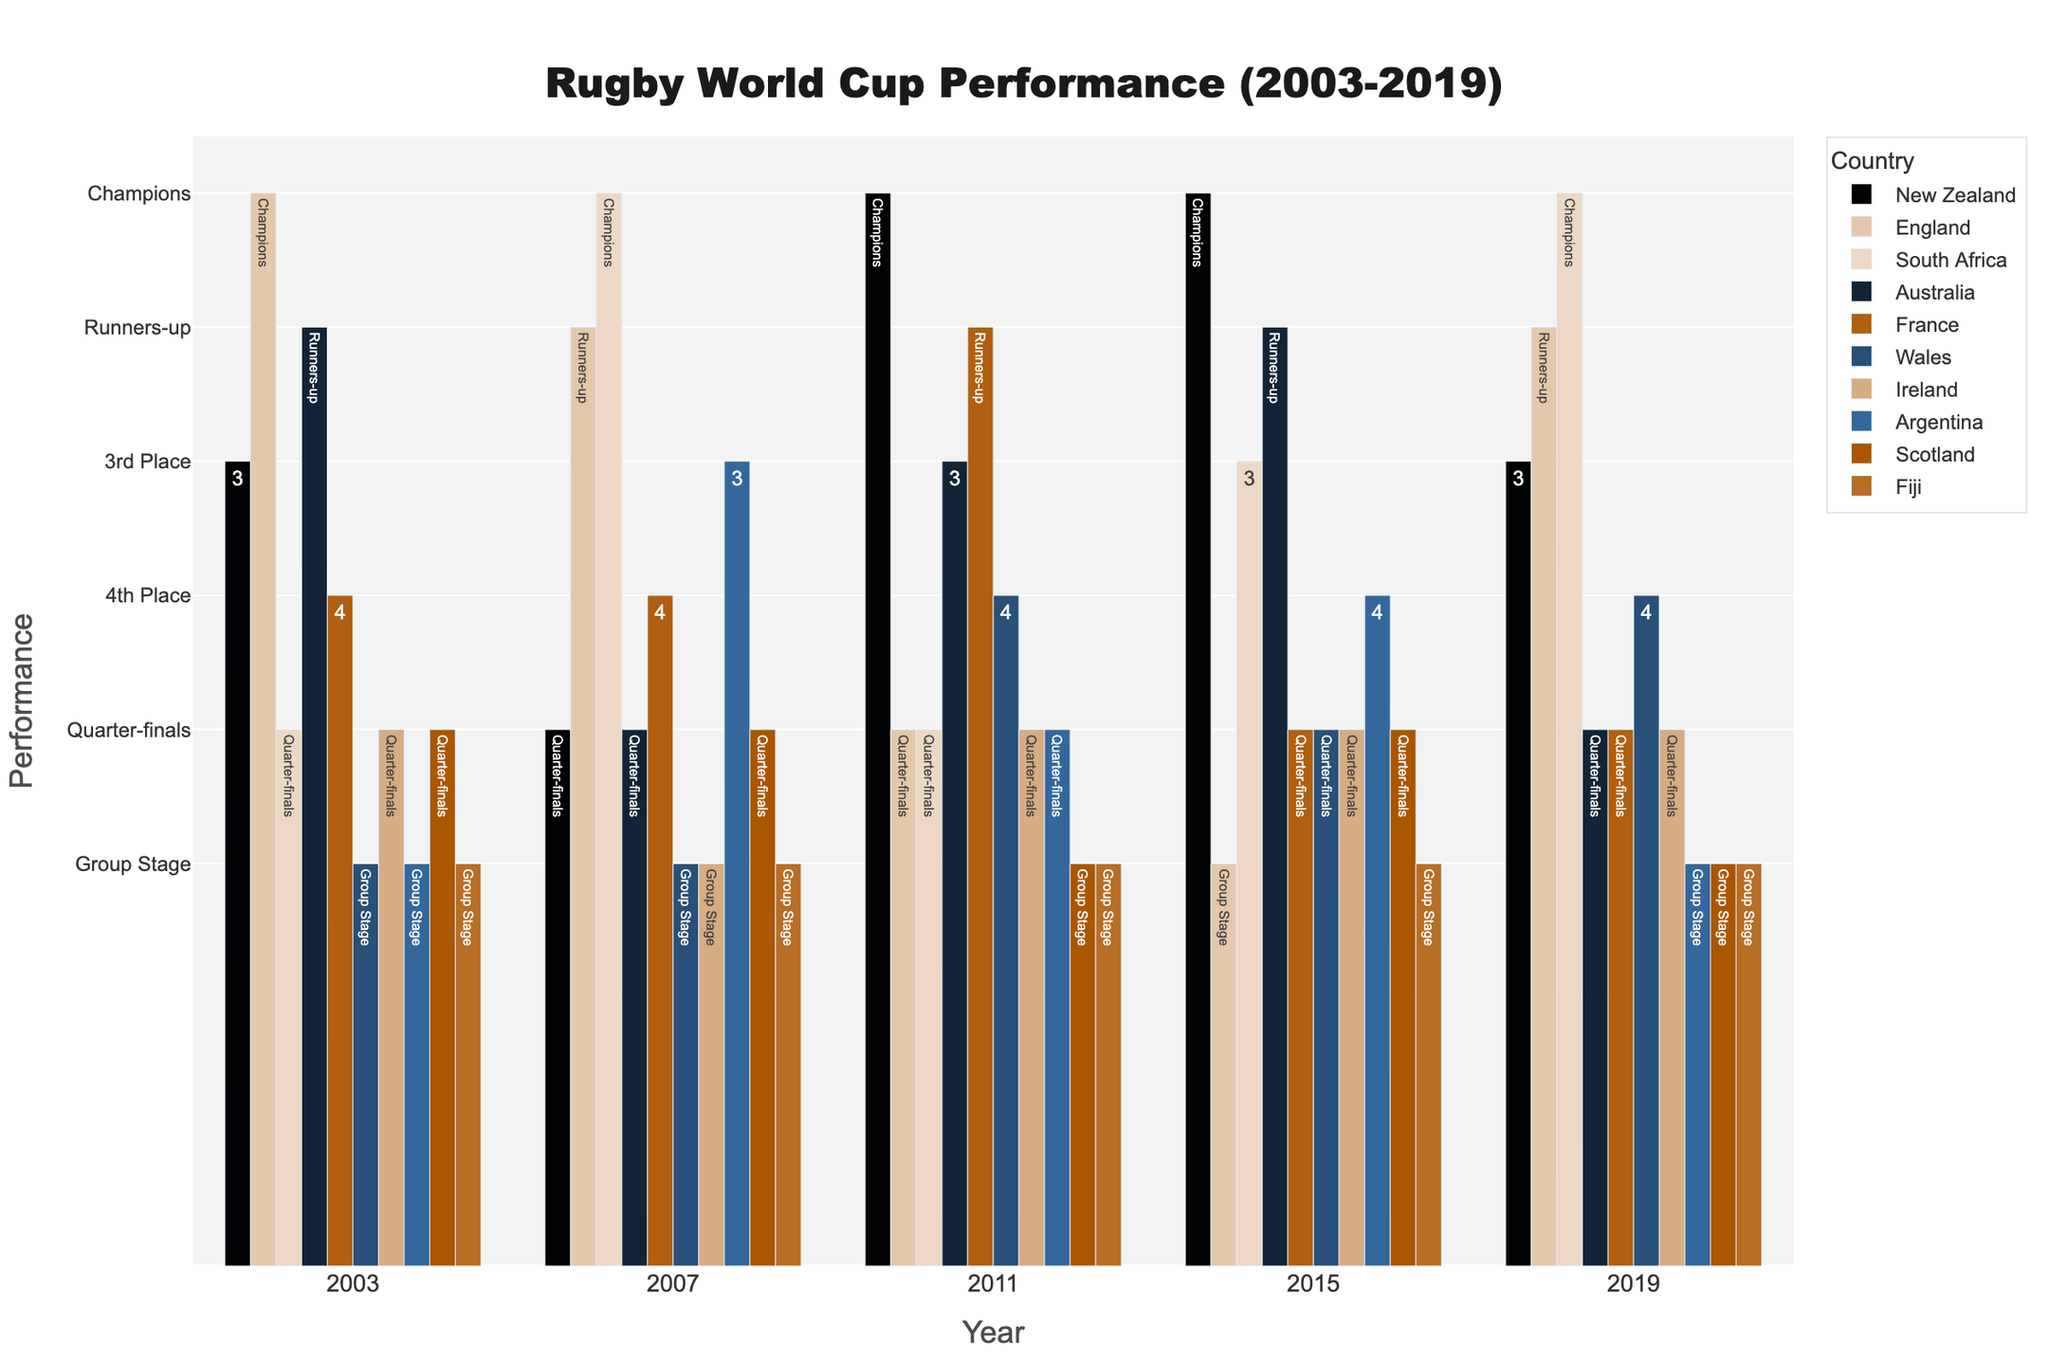What are the average performance ranks of New Zealand and South Africa from 2003 to 2019? To find the average rank, assign values to each performance (Champions=1, Runners-up=2, 3rd place=3, 4th place=4, Quarter-finals=5, Group Stage=6) and calculate the average. For New Zealand: (3+5+1+1+3)/5 = 2.6. For South Africa: (5+1+5+3+1)/5 = 3.
Answer: New Zealand: 2.6, South Africa: 3 Which team performed worse in 2011, New Zealand or England? New Zealand was the champion in 2011, while England reached the quarter-finals. Champions have a better performance rank compared to quarter-finalists.
Answer: England Among New Zealand, England, and South Africa, which team had more stable performance across the past five tournaments? Stability can be inferred by the consistency of rankings. New Zealand has ranks 3, quarter-finals, champions, champions, 3. England has ranks champions, runners-up, quarter-finals, group stage, runners-up. South Africa has ranks quarter-finals, champions, quarter-finals, 3, champions. New Zealand shows fewer fluctuations.
Answer: New Zealand What is the highest rank achieved by Wales over the past five tournaments? Look at Wales' performances: Group Stage, Group Stage, 4th place, Quarter-finals, 4th place. The highest rank is 4th place.
Answer: 4th place Which team has never moved past the Group Stage in the given years? Review the performance of each team. Fiji has been eliminated at the Group Stage in all tournaments from 2003 to 2019.
Answer: Fiji Compare the number of times England and France reached the semi-finals (Top 4) over the past five editions. For England: Champions (2003), Runners-up (2007), Quarter-finals (2011), Group Stage (2015), Runners-up (2019). They reached the semi-finals 3 times. For France: 4th place (2003, 2007), Runners-up (2011), Quarter-finals (2015, 2019). They reached the semi-finals 3 times.
Answer: Both 3 times Which year did New Zealand achieve the lowest performance rank? New Zealand's ranks were 3 (2003), quarter-finals (2007), champions (2011, 2015), 3 (2019). Quarter-finals in 2007 is the lowest rank.
Answer: 2007 Did any team other than New Zealand win the World Cup in consecutive editions from 2003 to 2019? Only New Zealand won consecutive titles (2011, 2015). No other team has achieved this.
Answer: No In 2007, which team had the best performance among New Zealand, England, Australia, and Argentina? In 2007, New Zealand reached the Quarter-finals, England were the Runners-up, Australia reached the Quarter-finals, and Argentina finished 3rd. The best performance was England as Runners-up.
Answer: England 